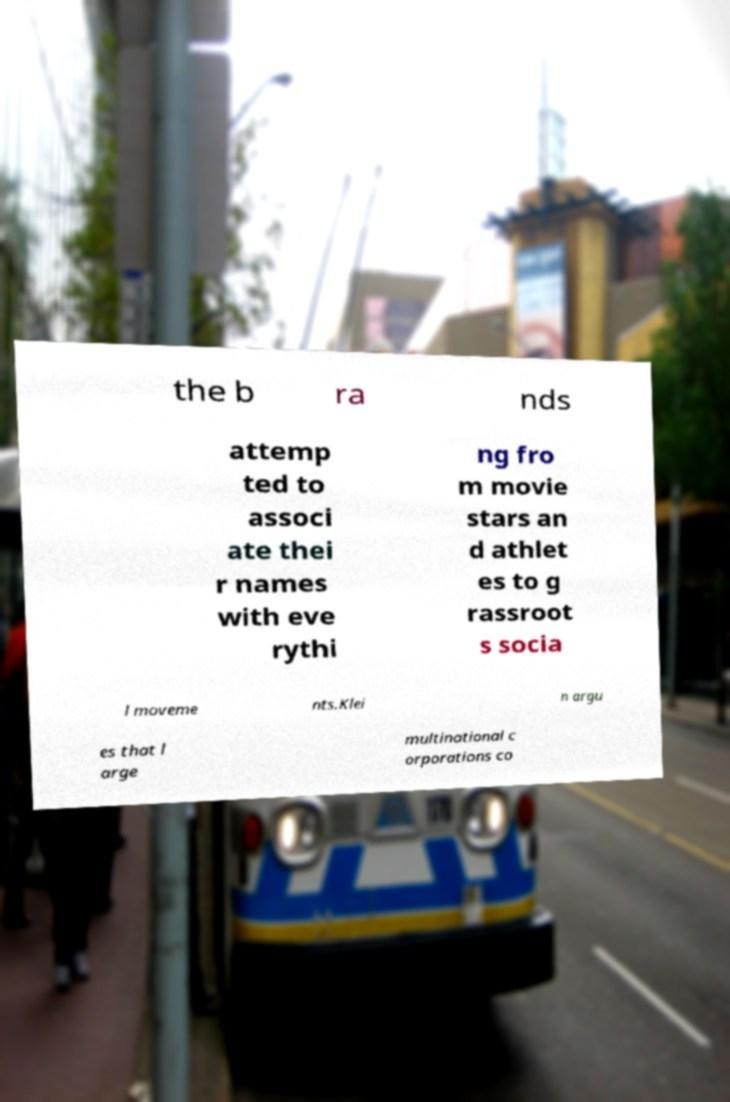What messages or text are displayed in this image? I need them in a readable, typed format. the b ra nds attemp ted to associ ate thei r names with eve rythi ng fro m movie stars an d athlet es to g rassroot s socia l moveme nts.Klei n argu es that l arge multinational c orporations co 